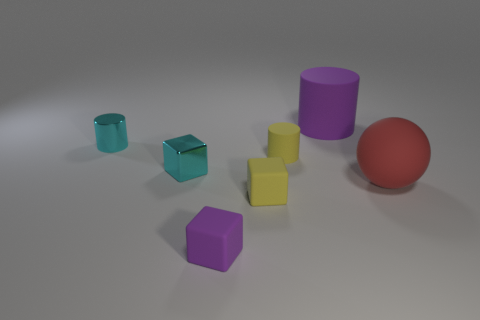Is there any other thing that has the same color as the sphere?
Ensure brevity in your answer.  No. Is the shiny cube the same color as the large cylinder?
Ensure brevity in your answer.  No. How many matte things are either small things or tiny purple things?
Your response must be concise. 3. There is a purple matte object in front of the big rubber thing that is behind the big sphere; is there a tiny purple object on the left side of it?
Your answer should be compact. No. There is a purple cylinder that is the same material as the yellow cylinder; what size is it?
Your answer should be very brief. Large. Are there any purple matte cubes on the left side of the large purple rubber object?
Give a very brief answer. Yes. Are there any big matte cylinders that are behind the tiny yellow matte object that is in front of the red rubber object?
Offer a terse response. Yes. There is a yellow matte thing in front of the large matte ball; does it have the same size as the yellow thing behind the large red thing?
Ensure brevity in your answer.  Yes. What number of tiny objects are either balls or red metal objects?
Offer a terse response. 0. What is the material of the cyan thing on the right side of the tiny thing behind the small matte cylinder?
Provide a succinct answer. Metal. 